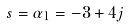<formula> <loc_0><loc_0><loc_500><loc_500>s = \alpha _ { 1 } = - 3 + 4 j</formula> 